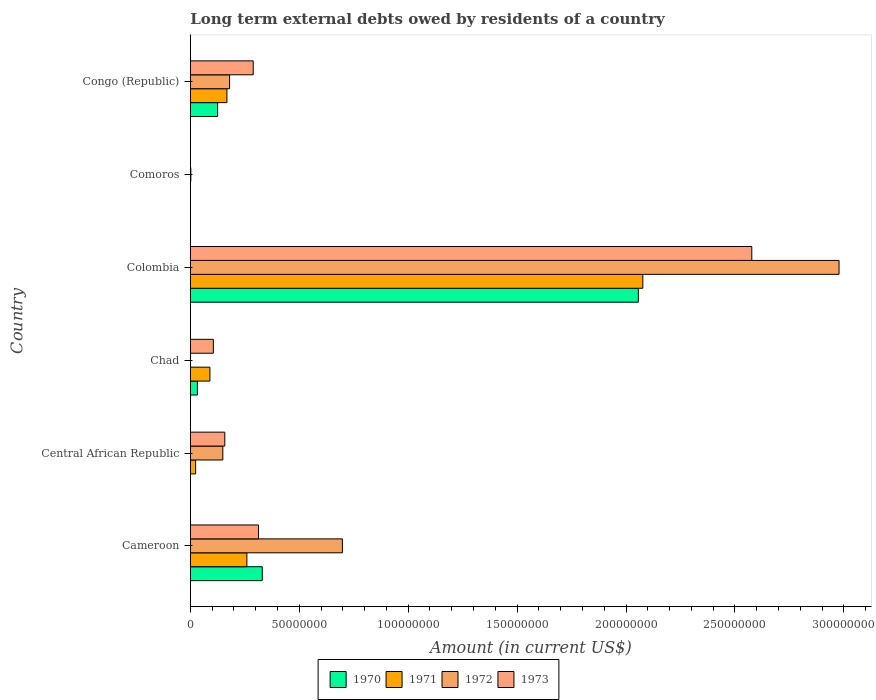How many groups of bars are there?
Your answer should be very brief. 6. Are the number of bars on each tick of the Y-axis equal?
Offer a terse response. No. What is the label of the 1st group of bars from the top?
Ensure brevity in your answer.  Congo (Republic). What is the amount of long-term external debts owed by residents in 1972 in Cameroon?
Give a very brief answer. 6.98e+07. Across all countries, what is the maximum amount of long-term external debts owed by residents in 1971?
Offer a very short reply. 2.08e+08. What is the total amount of long-term external debts owed by residents in 1970 in the graph?
Provide a succinct answer. 2.54e+08. What is the difference between the amount of long-term external debts owed by residents in 1971 in Cameroon and that in Chad?
Make the answer very short. 1.70e+07. What is the difference between the amount of long-term external debts owed by residents in 1971 in Cameroon and the amount of long-term external debts owed by residents in 1972 in Central African Republic?
Your answer should be compact. 1.10e+07. What is the average amount of long-term external debts owed by residents in 1972 per country?
Offer a terse response. 6.68e+07. What is the difference between the amount of long-term external debts owed by residents in 1970 and amount of long-term external debts owed by residents in 1973 in Cameroon?
Offer a very short reply. 1.72e+06. In how many countries, is the amount of long-term external debts owed by residents in 1972 greater than 240000000 US$?
Provide a short and direct response. 1. What is the ratio of the amount of long-term external debts owed by residents in 1971 in Cameroon to that in Central African Republic?
Your answer should be very brief. 10.61. Is the difference between the amount of long-term external debts owed by residents in 1970 in Cameroon and Colombia greater than the difference between the amount of long-term external debts owed by residents in 1973 in Cameroon and Colombia?
Provide a succinct answer. Yes. What is the difference between the highest and the second highest amount of long-term external debts owed by residents in 1970?
Your response must be concise. 1.73e+08. What is the difference between the highest and the lowest amount of long-term external debts owed by residents in 1972?
Offer a terse response. 2.98e+08. In how many countries, is the amount of long-term external debts owed by residents in 1972 greater than the average amount of long-term external debts owed by residents in 1972 taken over all countries?
Provide a short and direct response. 2. How many bars are there?
Ensure brevity in your answer.  20. Are all the bars in the graph horizontal?
Your response must be concise. Yes. What is the difference between two consecutive major ticks on the X-axis?
Ensure brevity in your answer.  5.00e+07. Does the graph contain any zero values?
Ensure brevity in your answer.  Yes. Does the graph contain grids?
Offer a very short reply. No. How many legend labels are there?
Provide a succinct answer. 4. What is the title of the graph?
Offer a very short reply. Long term external debts owed by residents of a country. Does "1989" appear as one of the legend labels in the graph?
Keep it short and to the point. No. What is the label or title of the X-axis?
Keep it short and to the point. Amount (in current US$). What is the Amount (in current US$) of 1970 in Cameroon?
Your answer should be compact. 3.30e+07. What is the Amount (in current US$) of 1971 in Cameroon?
Ensure brevity in your answer.  2.60e+07. What is the Amount (in current US$) in 1972 in Cameroon?
Provide a short and direct response. 6.98e+07. What is the Amount (in current US$) of 1973 in Cameroon?
Make the answer very short. 3.13e+07. What is the Amount (in current US$) in 1971 in Central African Republic?
Your response must be concise. 2.45e+06. What is the Amount (in current US$) in 1972 in Central African Republic?
Ensure brevity in your answer.  1.49e+07. What is the Amount (in current US$) of 1973 in Central African Republic?
Offer a terse response. 1.58e+07. What is the Amount (in current US$) of 1970 in Chad?
Your response must be concise. 3.26e+06. What is the Amount (in current US$) of 1971 in Chad?
Keep it short and to the point. 9.01e+06. What is the Amount (in current US$) in 1972 in Chad?
Offer a terse response. 0. What is the Amount (in current US$) in 1973 in Chad?
Your response must be concise. 1.06e+07. What is the Amount (in current US$) of 1970 in Colombia?
Provide a short and direct response. 2.06e+08. What is the Amount (in current US$) of 1971 in Colombia?
Your answer should be very brief. 2.08e+08. What is the Amount (in current US$) of 1972 in Colombia?
Your answer should be compact. 2.98e+08. What is the Amount (in current US$) of 1973 in Colombia?
Your response must be concise. 2.58e+08. What is the Amount (in current US$) in 1971 in Comoros?
Keep it short and to the point. 0. What is the Amount (in current US$) of 1972 in Comoros?
Offer a terse response. 2.48e+05. What is the Amount (in current US$) in 1973 in Comoros?
Provide a succinct answer. 5.40e+04. What is the Amount (in current US$) of 1970 in Congo (Republic)?
Keep it short and to the point. 1.26e+07. What is the Amount (in current US$) in 1971 in Congo (Republic)?
Your answer should be compact. 1.68e+07. What is the Amount (in current US$) of 1972 in Congo (Republic)?
Offer a terse response. 1.80e+07. What is the Amount (in current US$) of 1973 in Congo (Republic)?
Offer a terse response. 2.89e+07. Across all countries, what is the maximum Amount (in current US$) of 1970?
Keep it short and to the point. 2.06e+08. Across all countries, what is the maximum Amount (in current US$) of 1971?
Keep it short and to the point. 2.08e+08. Across all countries, what is the maximum Amount (in current US$) of 1972?
Provide a short and direct response. 2.98e+08. Across all countries, what is the maximum Amount (in current US$) of 1973?
Your answer should be compact. 2.58e+08. Across all countries, what is the minimum Amount (in current US$) of 1973?
Your response must be concise. 5.40e+04. What is the total Amount (in current US$) of 1970 in the graph?
Make the answer very short. 2.54e+08. What is the total Amount (in current US$) of 1971 in the graph?
Ensure brevity in your answer.  2.62e+08. What is the total Amount (in current US$) of 1972 in the graph?
Provide a short and direct response. 4.01e+08. What is the total Amount (in current US$) in 1973 in the graph?
Offer a terse response. 3.44e+08. What is the difference between the Amount (in current US$) of 1971 in Cameroon and that in Central African Republic?
Your answer should be compact. 2.35e+07. What is the difference between the Amount (in current US$) of 1972 in Cameroon and that in Central African Republic?
Make the answer very short. 5.49e+07. What is the difference between the Amount (in current US$) of 1973 in Cameroon and that in Central African Republic?
Make the answer very short. 1.55e+07. What is the difference between the Amount (in current US$) of 1970 in Cameroon and that in Chad?
Give a very brief answer. 2.98e+07. What is the difference between the Amount (in current US$) of 1971 in Cameroon and that in Chad?
Give a very brief answer. 1.70e+07. What is the difference between the Amount (in current US$) in 1973 in Cameroon and that in Chad?
Keep it short and to the point. 2.07e+07. What is the difference between the Amount (in current US$) in 1970 in Cameroon and that in Colombia?
Ensure brevity in your answer.  -1.73e+08. What is the difference between the Amount (in current US$) of 1971 in Cameroon and that in Colombia?
Provide a succinct answer. -1.82e+08. What is the difference between the Amount (in current US$) in 1972 in Cameroon and that in Colombia?
Give a very brief answer. -2.28e+08. What is the difference between the Amount (in current US$) in 1973 in Cameroon and that in Colombia?
Give a very brief answer. -2.26e+08. What is the difference between the Amount (in current US$) of 1972 in Cameroon and that in Comoros?
Provide a short and direct response. 6.96e+07. What is the difference between the Amount (in current US$) in 1973 in Cameroon and that in Comoros?
Offer a very short reply. 3.13e+07. What is the difference between the Amount (in current US$) in 1970 in Cameroon and that in Congo (Republic)?
Offer a terse response. 2.05e+07. What is the difference between the Amount (in current US$) of 1971 in Cameroon and that in Congo (Republic)?
Ensure brevity in your answer.  9.17e+06. What is the difference between the Amount (in current US$) in 1972 in Cameroon and that in Congo (Republic)?
Your answer should be very brief. 5.18e+07. What is the difference between the Amount (in current US$) of 1973 in Cameroon and that in Congo (Republic)?
Make the answer very short. 2.44e+06. What is the difference between the Amount (in current US$) in 1971 in Central African Republic and that in Chad?
Keep it short and to the point. -6.56e+06. What is the difference between the Amount (in current US$) in 1973 in Central African Republic and that in Chad?
Ensure brevity in your answer.  5.26e+06. What is the difference between the Amount (in current US$) in 1971 in Central African Republic and that in Colombia?
Give a very brief answer. -2.05e+08. What is the difference between the Amount (in current US$) of 1972 in Central African Republic and that in Colombia?
Offer a terse response. -2.83e+08. What is the difference between the Amount (in current US$) in 1973 in Central African Republic and that in Colombia?
Your answer should be compact. -2.42e+08. What is the difference between the Amount (in current US$) in 1972 in Central African Republic and that in Comoros?
Your answer should be very brief. 1.47e+07. What is the difference between the Amount (in current US$) of 1973 in Central African Republic and that in Comoros?
Your answer should be compact. 1.58e+07. What is the difference between the Amount (in current US$) in 1971 in Central African Republic and that in Congo (Republic)?
Offer a terse response. -1.44e+07. What is the difference between the Amount (in current US$) in 1972 in Central African Republic and that in Congo (Republic)?
Offer a terse response. -3.10e+06. What is the difference between the Amount (in current US$) in 1973 in Central African Republic and that in Congo (Republic)?
Provide a short and direct response. -1.30e+07. What is the difference between the Amount (in current US$) of 1970 in Chad and that in Colombia?
Provide a short and direct response. -2.02e+08. What is the difference between the Amount (in current US$) in 1971 in Chad and that in Colombia?
Your answer should be compact. -1.99e+08. What is the difference between the Amount (in current US$) of 1973 in Chad and that in Colombia?
Provide a short and direct response. -2.47e+08. What is the difference between the Amount (in current US$) of 1973 in Chad and that in Comoros?
Provide a short and direct response. 1.05e+07. What is the difference between the Amount (in current US$) of 1970 in Chad and that in Congo (Republic)?
Keep it short and to the point. -9.29e+06. What is the difference between the Amount (in current US$) of 1971 in Chad and that in Congo (Republic)?
Ensure brevity in your answer.  -7.80e+06. What is the difference between the Amount (in current US$) of 1973 in Chad and that in Congo (Republic)?
Provide a short and direct response. -1.83e+07. What is the difference between the Amount (in current US$) of 1972 in Colombia and that in Comoros?
Your response must be concise. 2.98e+08. What is the difference between the Amount (in current US$) in 1973 in Colombia and that in Comoros?
Keep it short and to the point. 2.58e+08. What is the difference between the Amount (in current US$) in 1970 in Colombia and that in Congo (Republic)?
Ensure brevity in your answer.  1.93e+08. What is the difference between the Amount (in current US$) in 1971 in Colombia and that in Congo (Republic)?
Provide a succinct answer. 1.91e+08. What is the difference between the Amount (in current US$) of 1972 in Colombia and that in Congo (Republic)?
Give a very brief answer. 2.80e+08. What is the difference between the Amount (in current US$) of 1973 in Colombia and that in Congo (Republic)?
Ensure brevity in your answer.  2.29e+08. What is the difference between the Amount (in current US$) in 1972 in Comoros and that in Congo (Republic)?
Keep it short and to the point. -1.78e+07. What is the difference between the Amount (in current US$) of 1973 in Comoros and that in Congo (Republic)?
Offer a very short reply. -2.88e+07. What is the difference between the Amount (in current US$) in 1970 in Cameroon and the Amount (in current US$) in 1971 in Central African Republic?
Provide a succinct answer. 3.06e+07. What is the difference between the Amount (in current US$) of 1970 in Cameroon and the Amount (in current US$) of 1972 in Central African Republic?
Offer a terse response. 1.81e+07. What is the difference between the Amount (in current US$) in 1970 in Cameroon and the Amount (in current US$) in 1973 in Central African Republic?
Make the answer very short. 1.72e+07. What is the difference between the Amount (in current US$) of 1971 in Cameroon and the Amount (in current US$) of 1972 in Central African Republic?
Your response must be concise. 1.10e+07. What is the difference between the Amount (in current US$) in 1971 in Cameroon and the Amount (in current US$) in 1973 in Central African Republic?
Offer a very short reply. 1.01e+07. What is the difference between the Amount (in current US$) of 1972 in Cameroon and the Amount (in current US$) of 1973 in Central African Republic?
Your answer should be very brief. 5.40e+07. What is the difference between the Amount (in current US$) in 1970 in Cameroon and the Amount (in current US$) in 1971 in Chad?
Give a very brief answer. 2.40e+07. What is the difference between the Amount (in current US$) in 1970 in Cameroon and the Amount (in current US$) in 1973 in Chad?
Your answer should be very brief. 2.25e+07. What is the difference between the Amount (in current US$) in 1971 in Cameroon and the Amount (in current US$) in 1973 in Chad?
Your response must be concise. 1.54e+07. What is the difference between the Amount (in current US$) in 1972 in Cameroon and the Amount (in current US$) in 1973 in Chad?
Offer a terse response. 5.92e+07. What is the difference between the Amount (in current US$) in 1970 in Cameroon and the Amount (in current US$) in 1971 in Colombia?
Provide a short and direct response. -1.75e+08. What is the difference between the Amount (in current US$) of 1970 in Cameroon and the Amount (in current US$) of 1972 in Colombia?
Your answer should be compact. -2.65e+08. What is the difference between the Amount (in current US$) of 1970 in Cameroon and the Amount (in current US$) of 1973 in Colombia?
Your response must be concise. -2.25e+08. What is the difference between the Amount (in current US$) in 1971 in Cameroon and the Amount (in current US$) in 1972 in Colombia?
Your answer should be very brief. -2.72e+08. What is the difference between the Amount (in current US$) of 1971 in Cameroon and the Amount (in current US$) of 1973 in Colombia?
Your answer should be compact. -2.32e+08. What is the difference between the Amount (in current US$) in 1972 in Cameroon and the Amount (in current US$) in 1973 in Colombia?
Your answer should be compact. -1.88e+08. What is the difference between the Amount (in current US$) of 1970 in Cameroon and the Amount (in current US$) of 1972 in Comoros?
Your answer should be compact. 3.28e+07. What is the difference between the Amount (in current US$) in 1970 in Cameroon and the Amount (in current US$) in 1973 in Comoros?
Provide a succinct answer. 3.30e+07. What is the difference between the Amount (in current US$) in 1971 in Cameroon and the Amount (in current US$) in 1972 in Comoros?
Offer a terse response. 2.57e+07. What is the difference between the Amount (in current US$) of 1971 in Cameroon and the Amount (in current US$) of 1973 in Comoros?
Keep it short and to the point. 2.59e+07. What is the difference between the Amount (in current US$) of 1972 in Cameroon and the Amount (in current US$) of 1973 in Comoros?
Make the answer very short. 6.98e+07. What is the difference between the Amount (in current US$) of 1970 in Cameroon and the Amount (in current US$) of 1971 in Congo (Republic)?
Your response must be concise. 1.62e+07. What is the difference between the Amount (in current US$) in 1970 in Cameroon and the Amount (in current US$) in 1972 in Congo (Republic)?
Provide a succinct answer. 1.50e+07. What is the difference between the Amount (in current US$) in 1970 in Cameroon and the Amount (in current US$) in 1973 in Congo (Republic)?
Make the answer very short. 4.16e+06. What is the difference between the Amount (in current US$) of 1971 in Cameroon and the Amount (in current US$) of 1972 in Congo (Republic)?
Your answer should be compact. 7.94e+06. What is the difference between the Amount (in current US$) of 1971 in Cameroon and the Amount (in current US$) of 1973 in Congo (Republic)?
Keep it short and to the point. -2.90e+06. What is the difference between the Amount (in current US$) in 1972 in Cameroon and the Amount (in current US$) in 1973 in Congo (Republic)?
Give a very brief answer. 4.09e+07. What is the difference between the Amount (in current US$) of 1971 in Central African Republic and the Amount (in current US$) of 1973 in Chad?
Keep it short and to the point. -8.13e+06. What is the difference between the Amount (in current US$) in 1972 in Central African Republic and the Amount (in current US$) in 1973 in Chad?
Ensure brevity in your answer.  4.35e+06. What is the difference between the Amount (in current US$) in 1971 in Central African Republic and the Amount (in current US$) in 1972 in Colombia?
Offer a terse response. -2.95e+08. What is the difference between the Amount (in current US$) of 1971 in Central African Republic and the Amount (in current US$) of 1973 in Colombia?
Give a very brief answer. -2.55e+08. What is the difference between the Amount (in current US$) of 1972 in Central African Republic and the Amount (in current US$) of 1973 in Colombia?
Your response must be concise. -2.43e+08. What is the difference between the Amount (in current US$) of 1971 in Central African Republic and the Amount (in current US$) of 1972 in Comoros?
Provide a succinct answer. 2.20e+06. What is the difference between the Amount (in current US$) in 1971 in Central African Republic and the Amount (in current US$) in 1973 in Comoros?
Your response must be concise. 2.40e+06. What is the difference between the Amount (in current US$) of 1972 in Central African Republic and the Amount (in current US$) of 1973 in Comoros?
Your answer should be very brief. 1.49e+07. What is the difference between the Amount (in current US$) of 1971 in Central African Republic and the Amount (in current US$) of 1972 in Congo (Republic)?
Your response must be concise. -1.56e+07. What is the difference between the Amount (in current US$) of 1971 in Central African Republic and the Amount (in current US$) of 1973 in Congo (Republic)?
Your answer should be compact. -2.64e+07. What is the difference between the Amount (in current US$) of 1972 in Central African Republic and the Amount (in current US$) of 1973 in Congo (Republic)?
Your answer should be compact. -1.39e+07. What is the difference between the Amount (in current US$) of 1970 in Chad and the Amount (in current US$) of 1971 in Colombia?
Your answer should be compact. -2.04e+08. What is the difference between the Amount (in current US$) of 1970 in Chad and the Amount (in current US$) of 1972 in Colombia?
Ensure brevity in your answer.  -2.94e+08. What is the difference between the Amount (in current US$) of 1970 in Chad and the Amount (in current US$) of 1973 in Colombia?
Your answer should be very brief. -2.54e+08. What is the difference between the Amount (in current US$) of 1971 in Chad and the Amount (in current US$) of 1972 in Colombia?
Your answer should be compact. -2.89e+08. What is the difference between the Amount (in current US$) of 1971 in Chad and the Amount (in current US$) of 1973 in Colombia?
Your answer should be compact. -2.49e+08. What is the difference between the Amount (in current US$) in 1970 in Chad and the Amount (in current US$) in 1972 in Comoros?
Your answer should be compact. 3.02e+06. What is the difference between the Amount (in current US$) in 1970 in Chad and the Amount (in current US$) in 1973 in Comoros?
Give a very brief answer. 3.21e+06. What is the difference between the Amount (in current US$) of 1971 in Chad and the Amount (in current US$) of 1972 in Comoros?
Provide a short and direct response. 8.76e+06. What is the difference between the Amount (in current US$) of 1971 in Chad and the Amount (in current US$) of 1973 in Comoros?
Keep it short and to the point. 8.95e+06. What is the difference between the Amount (in current US$) in 1970 in Chad and the Amount (in current US$) in 1971 in Congo (Republic)?
Make the answer very short. -1.35e+07. What is the difference between the Amount (in current US$) in 1970 in Chad and the Amount (in current US$) in 1972 in Congo (Republic)?
Provide a succinct answer. -1.48e+07. What is the difference between the Amount (in current US$) of 1970 in Chad and the Amount (in current US$) of 1973 in Congo (Republic)?
Provide a succinct answer. -2.56e+07. What is the difference between the Amount (in current US$) in 1971 in Chad and the Amount (in current US$) in 1972 in Congo (Republic)?
Give a very brief answer. -9.03e+06. What is the difference between the Amount (in current US$) of 1971 in Chad and the Amount (in current US$) of 1973 in Congo (Republic)?
Your answer should be compact. -1.99e+07. What is the difference between the Amount (in current US$) of 1970 in Colombia and the Amount (in current US$) of 1972 in Comoros?
Offer a very short reply. 2.05e+08. What is the difference between the Amount (in current US$) of 1970 in Colombia and the Amount (in current US$) of 1973 in Comoros?
Your answer should be compact. 2.06e+08. What is the difference between the Amount (in current US$) in 1971 in Colombia and the Amount (in current US$) in 1972 in Comoros?
Provide a succinct answer. 2.07e+08. What is the difference between the Amount (in current US$) of 1971 in Colombia and the Amount (in current US$) of 1973 in Comoros?
Give a very brief answer. 2.08e+08. What is the difference between the Amount (in current US$) of 1972 in Colombia and the Amount (in current US$) of 1973 in Comoros?
Your answer should be very brief. 2.98e+08. What is the difference between the Amount (in current US$) in 1970 in Colombia and the Amount (in current US$) in 1971 in Congo (Republic)?
Offer a very short reply. 1.89e+08. What is the difference between the Amount (in current US$) of 1970 in Colombia and the Amount (in current US$) of 1972 in Congo (Republic)?
Your answer should be very brief. 1.88e+08. What is the difference between the Amount (in current US$) of 1970 in Colombia and the Amount (in current US$) of 1973 in Congo (Republic)?
Give a very brief answer. 1.77e+08. What is the difference between the Amount (in current US$) in 1971 in Colombia and the Amount (in current US$) in 1972 in Congo (Republic)?
Make the answer very short. 1.90e+08. What is the difference between the Amount (in current US$) of 1971 in Colombia and the Amount (in current US$) of 1973 in Congo (Republic)?
Provide a succinct answer. 1.79e+08. What is the difference between the Amount (in current US$) of 1972 in Colombia and the Amount (in current US$) of 1973 in Congo (Republic)?
Provide a short and direct response. 2.69e+08. What is the difference between the Amount (in current US$) in 1972 in Comoros and the Amount (in current US$) in 1973 in Congo (Republic)?
Ensure brevity in your answer.  -2.86e+07. What is the average Amount (in current US$) of 1970 per country?
Offer a terse response. 4.24e+07. What is the average Amount (in current US$) of 1971 per country?
Your answer should be compact. 4.37e+07. What is the average Amount (in current US$) in 1972 per country?
Provide a succinct answer. 6.68e+07. What is the average Amount (in current US$) of 1973 per country?
Give a very brief answer. 5.74e+07. What is the difference between the Amount (in current US$) of 1970 and Amount (in current US$) of 1971 in Cameroon?
Give a very brief answer. 7.06e+06. What is the difference between the Amount (in current US$) of 1970 and Amount (in current US$) of 1972 in Cameroon?
Offer a terse response. -3.68e+07. What is the difference between the Amount (in current US$) in 1970 and Amount (in current US$) in 1973 in Cameroon?
Offer a terse response. 1.72e+06. What is the difference between the Amount (in current US$) of 1971 and Amount (in current US$) of 1972 in Cameroon?
Ensure brevity in your answer.  -4.38e+07. What is the difference between the Amount (in current US$) in 1971 and Amount (in current US$) in 1973 in Cameroon?
Ensure brevity in your answer.  -5.34e+06. What is the difference between the Amount (in current US$) of 1972 and Amount (in current US$) of 1973 in Cameroon?
Offer a terse response. 3.85e+07. What is the difference between the Amount (in current US$) of 1971 and Amount (in current US$) of 1972 in Central African Republic?
Offer a terse response. -1.25e+07. What is the difference between the Amount (in current US$) in 1971 and Amount (in current US$) in 1973 in Central African Republic?
Provide a succinct answer. -1.34e+07. What is the difference between the Amount (in current US$) of 1972 and Amount (in current US$) of 1973 in Central African Republic?
Give a very brief answer. -9.04e+05. What is the difference between the Amount (in current US$) of 1970 and Amount (in current US$) of 1971 in Chad?
Keep it short and to the point. -5.74e+06. What is the difference between the Amount (in current US$) in 1970 and Amount (in current US$) in 1973 in Chad?
Your answer should be compact. -7.32e+06. What is the difference between the Amount (in current US$) in 1971 and Amount (in current US$) in 1973 in Chad?
Provide a succinct answer. -1.57e+06. What is the difference between the Amount (in current US$) in 1970 and Amount (in current US$) in 1971 in Colombia?
Offer a terse response. -2.06e+06. What is the difference between the Amount (in current US$) in 1970 and Amount (in current US$) in 1972 in Colombia?
Keep it short and to the point. -9.21e+07. What is the difference between the Amount (in current US$) of 1970 and Amount (in current US$) of 1973 in Colombia?
Provide a short and direct response. -5.21e+07. What is the difference between the Amount (in current US$) in 1971 and Amount (in current US$) in 1972 in Colombia?
Keep it short and to the point. -9.01e+07. What is the difference between the Amount (in current US$) in 1971 and Amount (in current US$) in 1973 in Colombia?
Make the answer very short. -5.00e+07. What is the difference between the Amount (in current US$) of 1972 and Amount (in current US$) of 1973 in Colombia?
Ensure brevity in your answer.  4.00e+07. What is the difference between the Amount (in current US$) in 1972 and Amount (in current US$) in 1973 in Comoros?
Your response must be concise. 1.94e+05. What is the difference between the Amount (in current US$) of 1970 and Amount (in current US$) of 1971 in Congo (Republic)?
Make the answer very short. -4.26e+06. What is the difference between the Amount (in current US$) in 1970 and Amount (in current US$) in 1972 in Congo (Republic)?
Offer a terse response. -5.48e+06. What is the difference between the Amount (in current US$) of 1970 and Amount (in current US$) of 1973 in Congo (Republic)?
Your answer should be compact. -1.63e+07. What is the difference between the Amount (in current US$) of 1971 and Amount (in current US$) of 1972 in Congo (Republic)?
Ensure brevity in your answer.  -1.23e+06. What is the difference between the Amount (in current US$) of 1971 and Amount (in current US$) of 1973 in Congo (Republic)?
Your answer should be compact. -1.21e+07. What is the difference between the Amount (in current US$) in 1972 and Amount (in current US$) in 1973 in Congo (Republic)?
Your answer should be very brief. -1.08e+07. What is the ratio of the Amount (in current US$) of 1971 in Cameroon to that in Central African Republic?
Your answer should be compact. 10.61. What is the ratio of the Amount (in current US$) of 1972 in Cameroon to that in Central African Republic?
Make the answer very short. 4.67. What is the ratio of the Amount (in current US$) of 1973 in Cameroon to that in Central African Republic?
Keep it short and to the point. 1.98. What is the ratio of the Amount (in current US$) in 1970 in Cameroon to that in Chad?
Your answer should be compact. 10.12. What is the ratio of the Amount (in current US$) in 1971 in Cameroon to that in Chad?
Your response must be concise. 2.88. What is the ratio of the Amount (in current US$) of 1973 in Cameroon to that in Chad?
Give a very brief answer. 2.96. What is the ratio of the Amount (in current US$) in 1970 in Cameroon to that in Colombia?
Keep it short and to the point. 0.16. What is the ratio of the Amount (in current US$) in 1971 in Cameroon to that in Colombia?
Provide a succinct answer. 0.13. What is the ratio of the Amount (in current US$) of 1972 in Cameroon to that in Colombia?
Your response must be concise. 0.23. What is the ratio of the Amount (in current US$) of 1973 in Cameroon to that in Colombia?
Provide a succinct answer. 0.12. What is the ratio of the Amount (in current US$) of 1972 in Cameroon to that in Comoros?
Offer a terse response. 281.47. What is the ratio of the Amount (in current US$) of 1973 in Cameroon to that in Comoros?
Provide a short and direct response. 579.91. What is the ratio of the Amount (in current US$) of 1970 in Cameroon to that in Congo (Republic)?
Your response must be concise. 2.63. What is the ratio of the Amount (in current US$) in 1971 in Cameroon to that in Congo (Republic)?
Keep it short and to the point. 1.55. What is the ratio of the Amount (in current US$) in 1972 in Cameroon to that in Congo (Republic)?
Your response must be concise. 3.87. What is the ratio of the Amount (in current US$) of 1973 in Cameroon to that in Congo (Republic)?
Make the answer very short. 1.08. What is the ratio of the Amount (in current US$) in 1971 in Central African Republic to that in Chad?
Provide a short and direct response. 0.27. What is the ratio of the Amount (in current US$) in 1973 in Central African Republic to that in Chad?
Give a very brief answer. 1.5. What is the ratio of the Amount (in current US$) in 1971 in Central African Republic to that in Colombia?
Your answer should be very brief. 0.01. What is the ratio of the Amount (in current US$) in 1972 in Central African Republic to that in Colombia?
Provide a succinct answer. 0.05. What is the ratio of the Amount (in current US$) of 1973 in Central African Republic to that in Colombia?
Your response must be concise. 0.06. What is the ratio of the Amount (in current US$) of 1972 in Central African Republic to that in Comoros?
Offer a very short reply. 60.21. What is the ratio of the Amount (in current US$) of 1973 in Central African Republic to that in Comoros?
Your answer should be very brief. 293.26. What is the ratio of the Amount (in current US$) of 1971 in Central African Republic to that in Congo (Republic)?
Keep it short and to the point. 0.15. What is the ratio of the Amount (in current US$) of 1972 in Central African Republic to that in Congo (Republic)?
Ensure brevity in your answer.  0.83. What is the ratio of the Amount (in current US$) of 1973 in Central African Republic to that in Congo (Republic)?
Offer a terse response. 0.55. What is the ratio of the Amount (in current US$) in 1970 in Chad to that in Colombia?
Your answer should be very brief. 0.02. What is the ratio of the Amount (in current US$) in 1971 in Chad to that in Colombia?
Make the answer very short. 0.04. What is the ratio of the Amount (in current US$) in 1973 in Chad to that in Colombia?
Keep it short and to the point. 0.04. What is the ratio of the Amount (in current US$) in 1973 in Chad to that in Comoros?
Offer a terse response. 195.94. What is the ratio of the Amount (in current US$) in 1970 in Chad to that in Congo (Republic)?
Offer a very short reply. 0.26. What is the ratio of the Amount (in current US$) in 1971 in Chad to that in Congo (Republic)?
Your answer should be compact. 0.54. What is the ratio of the Amount (in current US$) in 1973 in Chad to that in Congo (Republic)?
Your answer should be very brief. 0.37. What is the ratio of the Amount (in current US$) in 1972 in Colombia to that in Comoros?
Your answer should be very brief. 1200.66. What is the ratio of the Amount (in current US$) of 1973 in Colombia to that in Comoros?
Keep it short and to the point. 4772.54. What is the ratio of the Amount (in current US$) in 1970 in Colombia to that in Congo (Republic)?
Give a very brief answer. 16.39. What is the ratio of the Amount (in current US$) of 1971 in Colombia to that in Congo (Republic)?
Your answer should be very brief. 12.36. What is the ratio of the Amount (in current US$) of 1972 in Colombia to that in Congo (Republic)?
Your response must be concise. 16.51. What is the ratio of the Amount (in current US$) in 1973 in Colombia to that in Congo (Republic)?
Your answer should be very brief. 8.92. What is the ratio of the Amount (in current US$) in 1972 in Comoros to that in Congo (Republic)?
Ensure brevity in your answer.  0.01. What is the ratio of the Amount (in current US$) of 1973 in Comoros to that in Congo (Republic)?
Provide a short and direct response. 0. What is the difference between the highest and the second highest Amount (in current US$) in 1970?
Offer a terse response. 1.73e+08. What is the difference between the highest and the second highest Amount (in current US$) of 1971?
Make the answer very short. 1.82e+08. What is the difference between the highest and the second highest Amount (in current US$) of 1972?
Offer a very short reply. 2.28e+08. What is the difference between the highest and the second highest Amount (in current US$) in 1973?
Ensure brevity in your answer.  2.26e+08. What is the difference between the highest and the lowest Amount (in current US$) of 1970?
Provide a short and direct response. 2.06e+08. What is the difference between the highest and the lowest Amount (in current US$) of 1971?
Your answer should be very brief. 2.08e+08. What is the difference between the highest and the lowest Amount (in current US$) of 1972?
Your answer should be very brief. 2.98e+08. What is the difference between the highest and the lowest Amount (in current US$) of 1973?
Keep it short and to the point. 2.58e+08. 